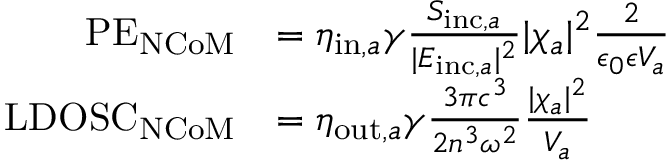<formula> <loc_0><loc_0><loc_500><loc_500>\begin{array} { r l } { P E _ { N C o M } } & { = \eta _ { i n , a } \gamma \frac { S _ { i n c , a } } { | E _ { i n c , a } | ^ { 2 } } | \chi _ { a } | ^ { 2 } \frac { 2 } { \epsilon _ { 0 } \epsilon V _ { a } } } \\ { L D O S C _ { N C o M } } & { = \eta _ { o u t , a } \gamma \frac { 3 \pi c ^ { 3 } } { 2 n ^ { 3 } \omega ^ { 2 } } \frac { | \chi _ { a } | ^ { 2 } } { V _ { a } } } \end{array}</formula> 